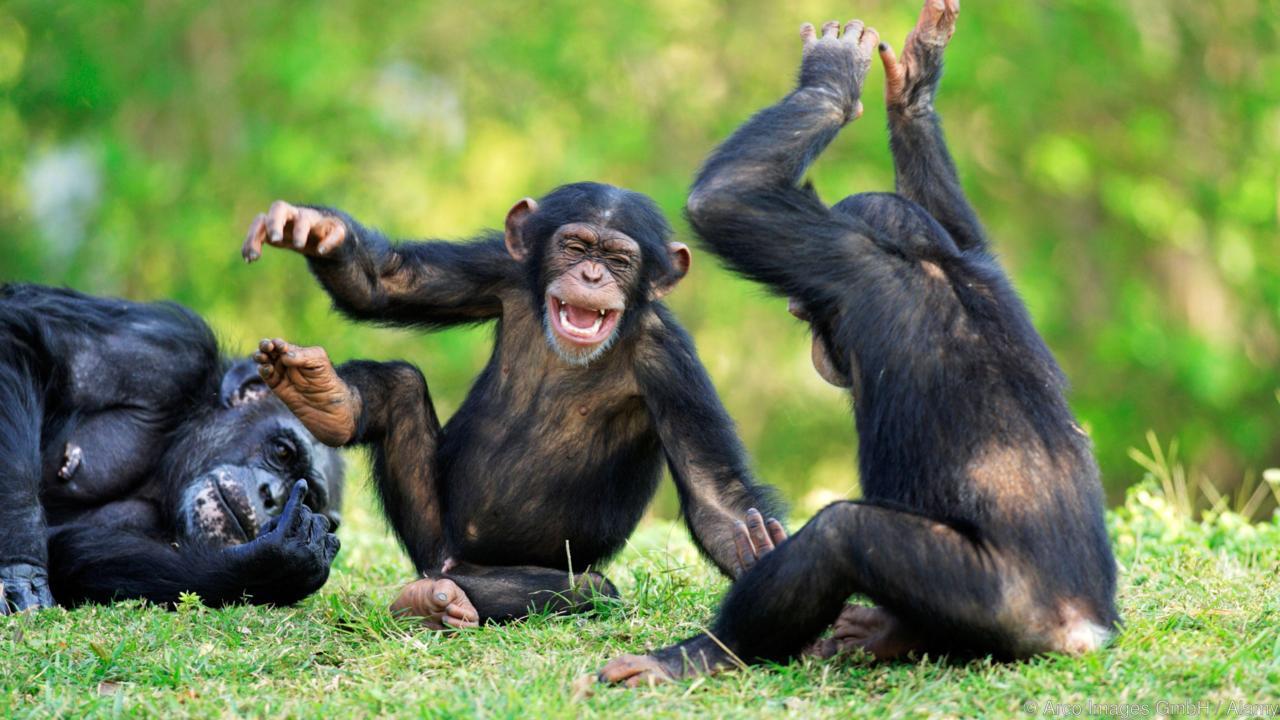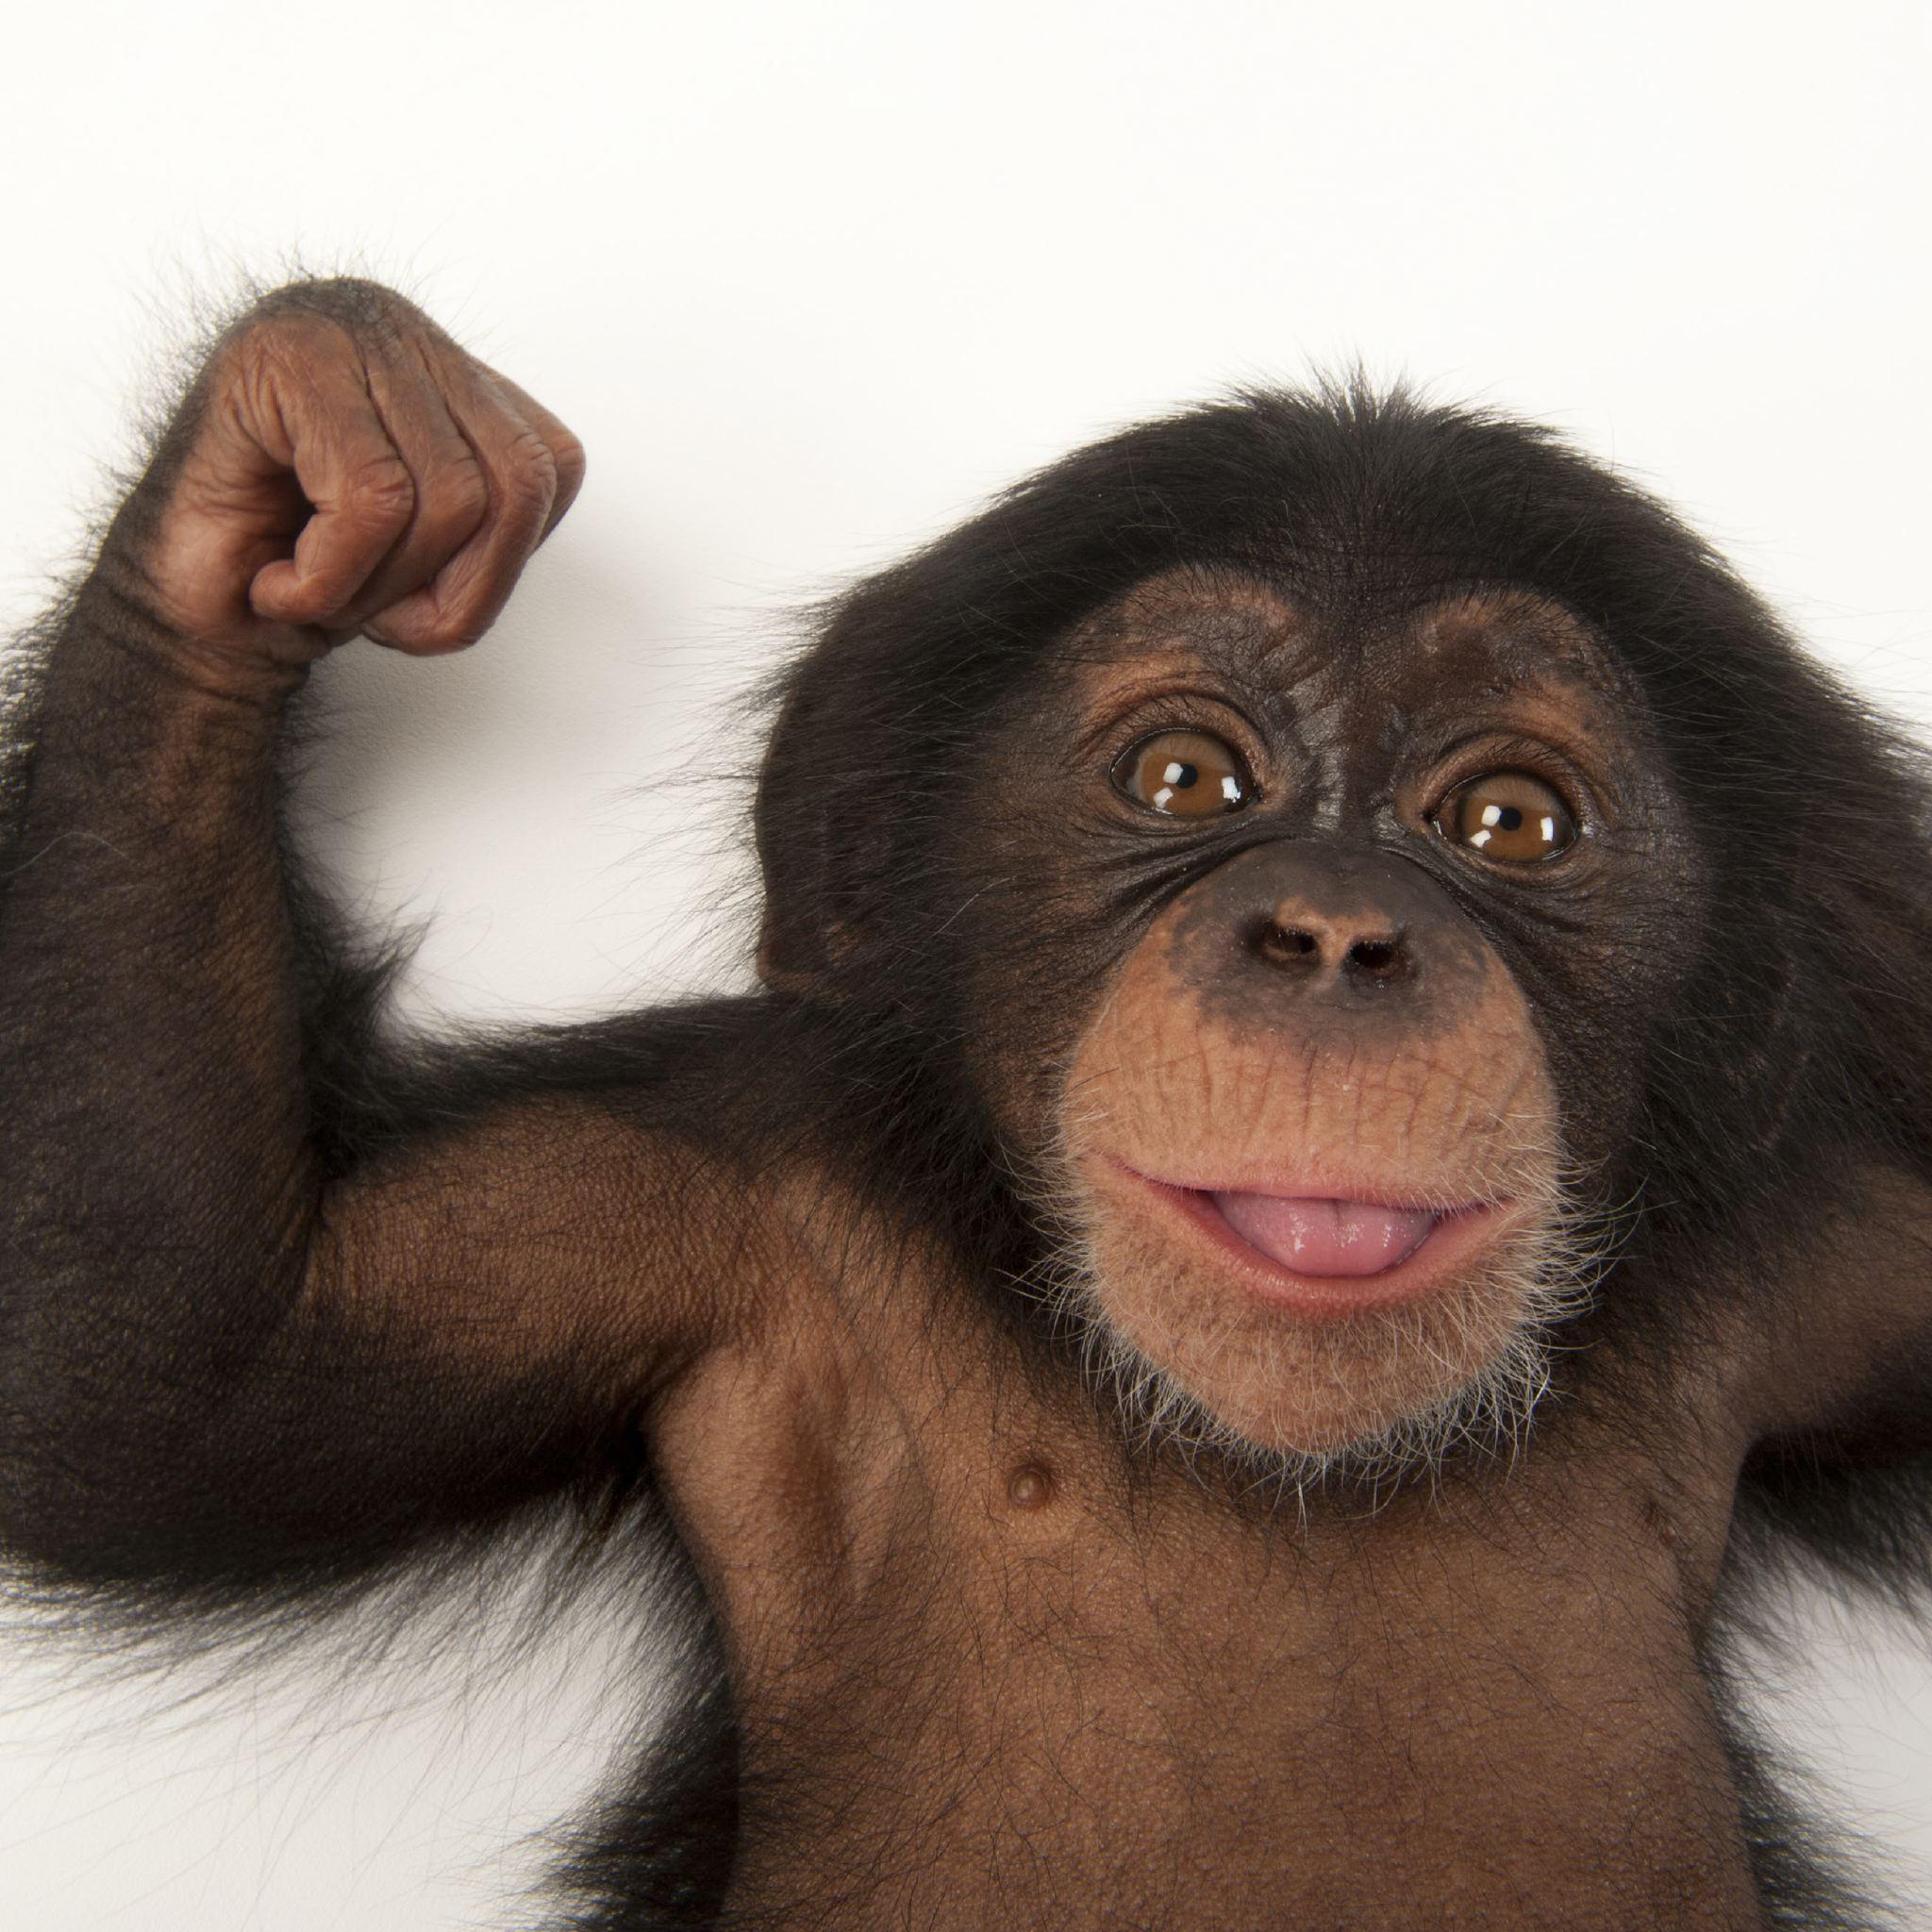The first image is the image on the left, the second image is the image on the right. Considering the images on both sides, is "An image shows at least one young chimp with an older chimp nearby." valid? Answer yes or no. Yes. 